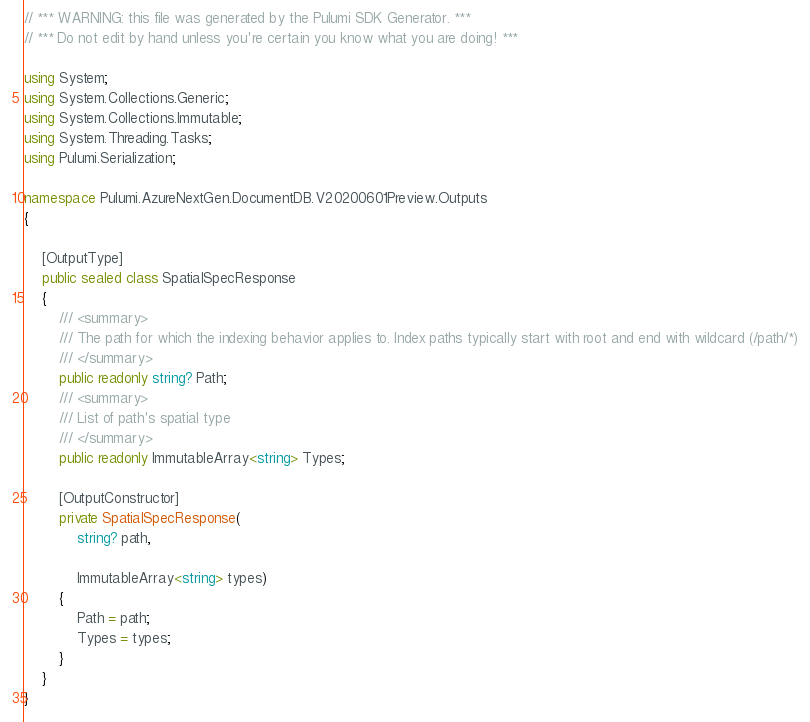<code> <loc_0><loc_0><loc_500><loc_500><_C#_>// *** WARNING: this file was generated by the Pulumi SDK Generator. ***
// *** Do not edit by hand unless you're certain you know what you are doing! ***

using System;
using System.Collections.Generic;
using System.Collections.Immutable;
using System.Threading.Tasks;
using Pulumi.Serialization;

namespace Pulumi.AzureNextGen.DocumentDB.V20200601Preview.Outputs
{

    [OutputType]
    public sealed class SpatialSpecResponse
    {
        /// <summary>
        /// The path for which the indexing behavior applies to. Index paths typically start with root and end with wildcard (/path/*)
        /// </summary>
        public readonly string? Path;
        /// <summary>
        /// List of path's spatial type
        /// </summary>
        public readonly ImmutableArray<string> Types;

        [OutputConstructor]
        private SpatialSpecResponse(
            string? path,

            ImmutableArray<string> types)
        {
            Path = path;
            Types = types;
        }
    }
}
</code> 